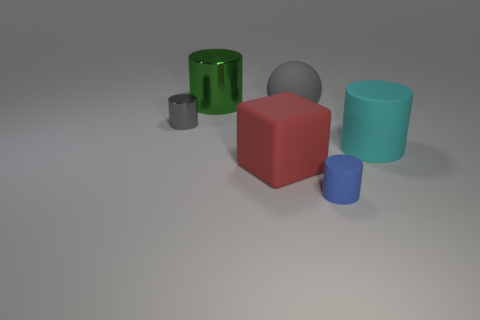What is the size of the shiny object that is the same color as the ball?
Make the answer very short. Small. The large object that is in front of the cyan matte object in front of the big gray rubber thing is made of what material?
Your response must be concise. Rubber. What number of things are red cubes or cylinders left of the cyan rubber cylinder?
Offer a very short reply. 4. There is a cyan cylinder that is the same material as the gray sphere; what size is it?
Offer a very short reply. Large. What number of purple objects are matte cubes or large spheres?
Keep it short and to the point. 0. What is the shape of the thing that is the same color as the rubber ball?
Provide a succinct answer. Cylinder. Is there any other thing that is made of the same material as the big gray sphere?
Ensure brevity in your answer.  Yes. Is the shape of the large metallic thing behind the gray shiny thing the same as the tiny object that is left of the small blue cylinder?
Ensure brevity in your answer.  Yes. What number of big green metallic cylinders are there?
Provide a short and direct response. 1. There is a tiny thing that is made of the same material as the big sphere; what shape is it?
Your response must be concise. Cylinder. 